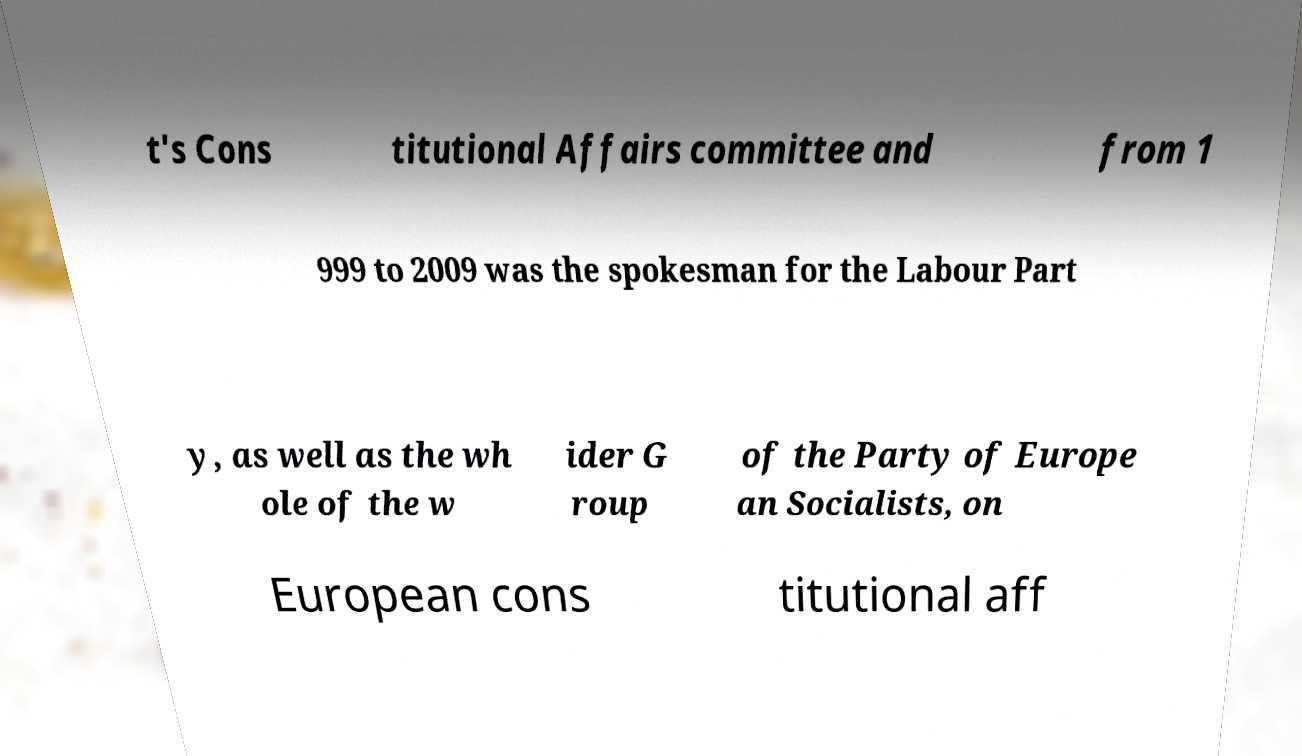There's text embedded in this image that I need extracted. Can you transcribe it verbatim? t's Cons titutional Affairs committee and from 1 999 to 2009 was the spokesman for the Labour Part y, as well as the wh ole of the w ider G roup of the Party of Europe an Socialists, on European cons titutional aff 